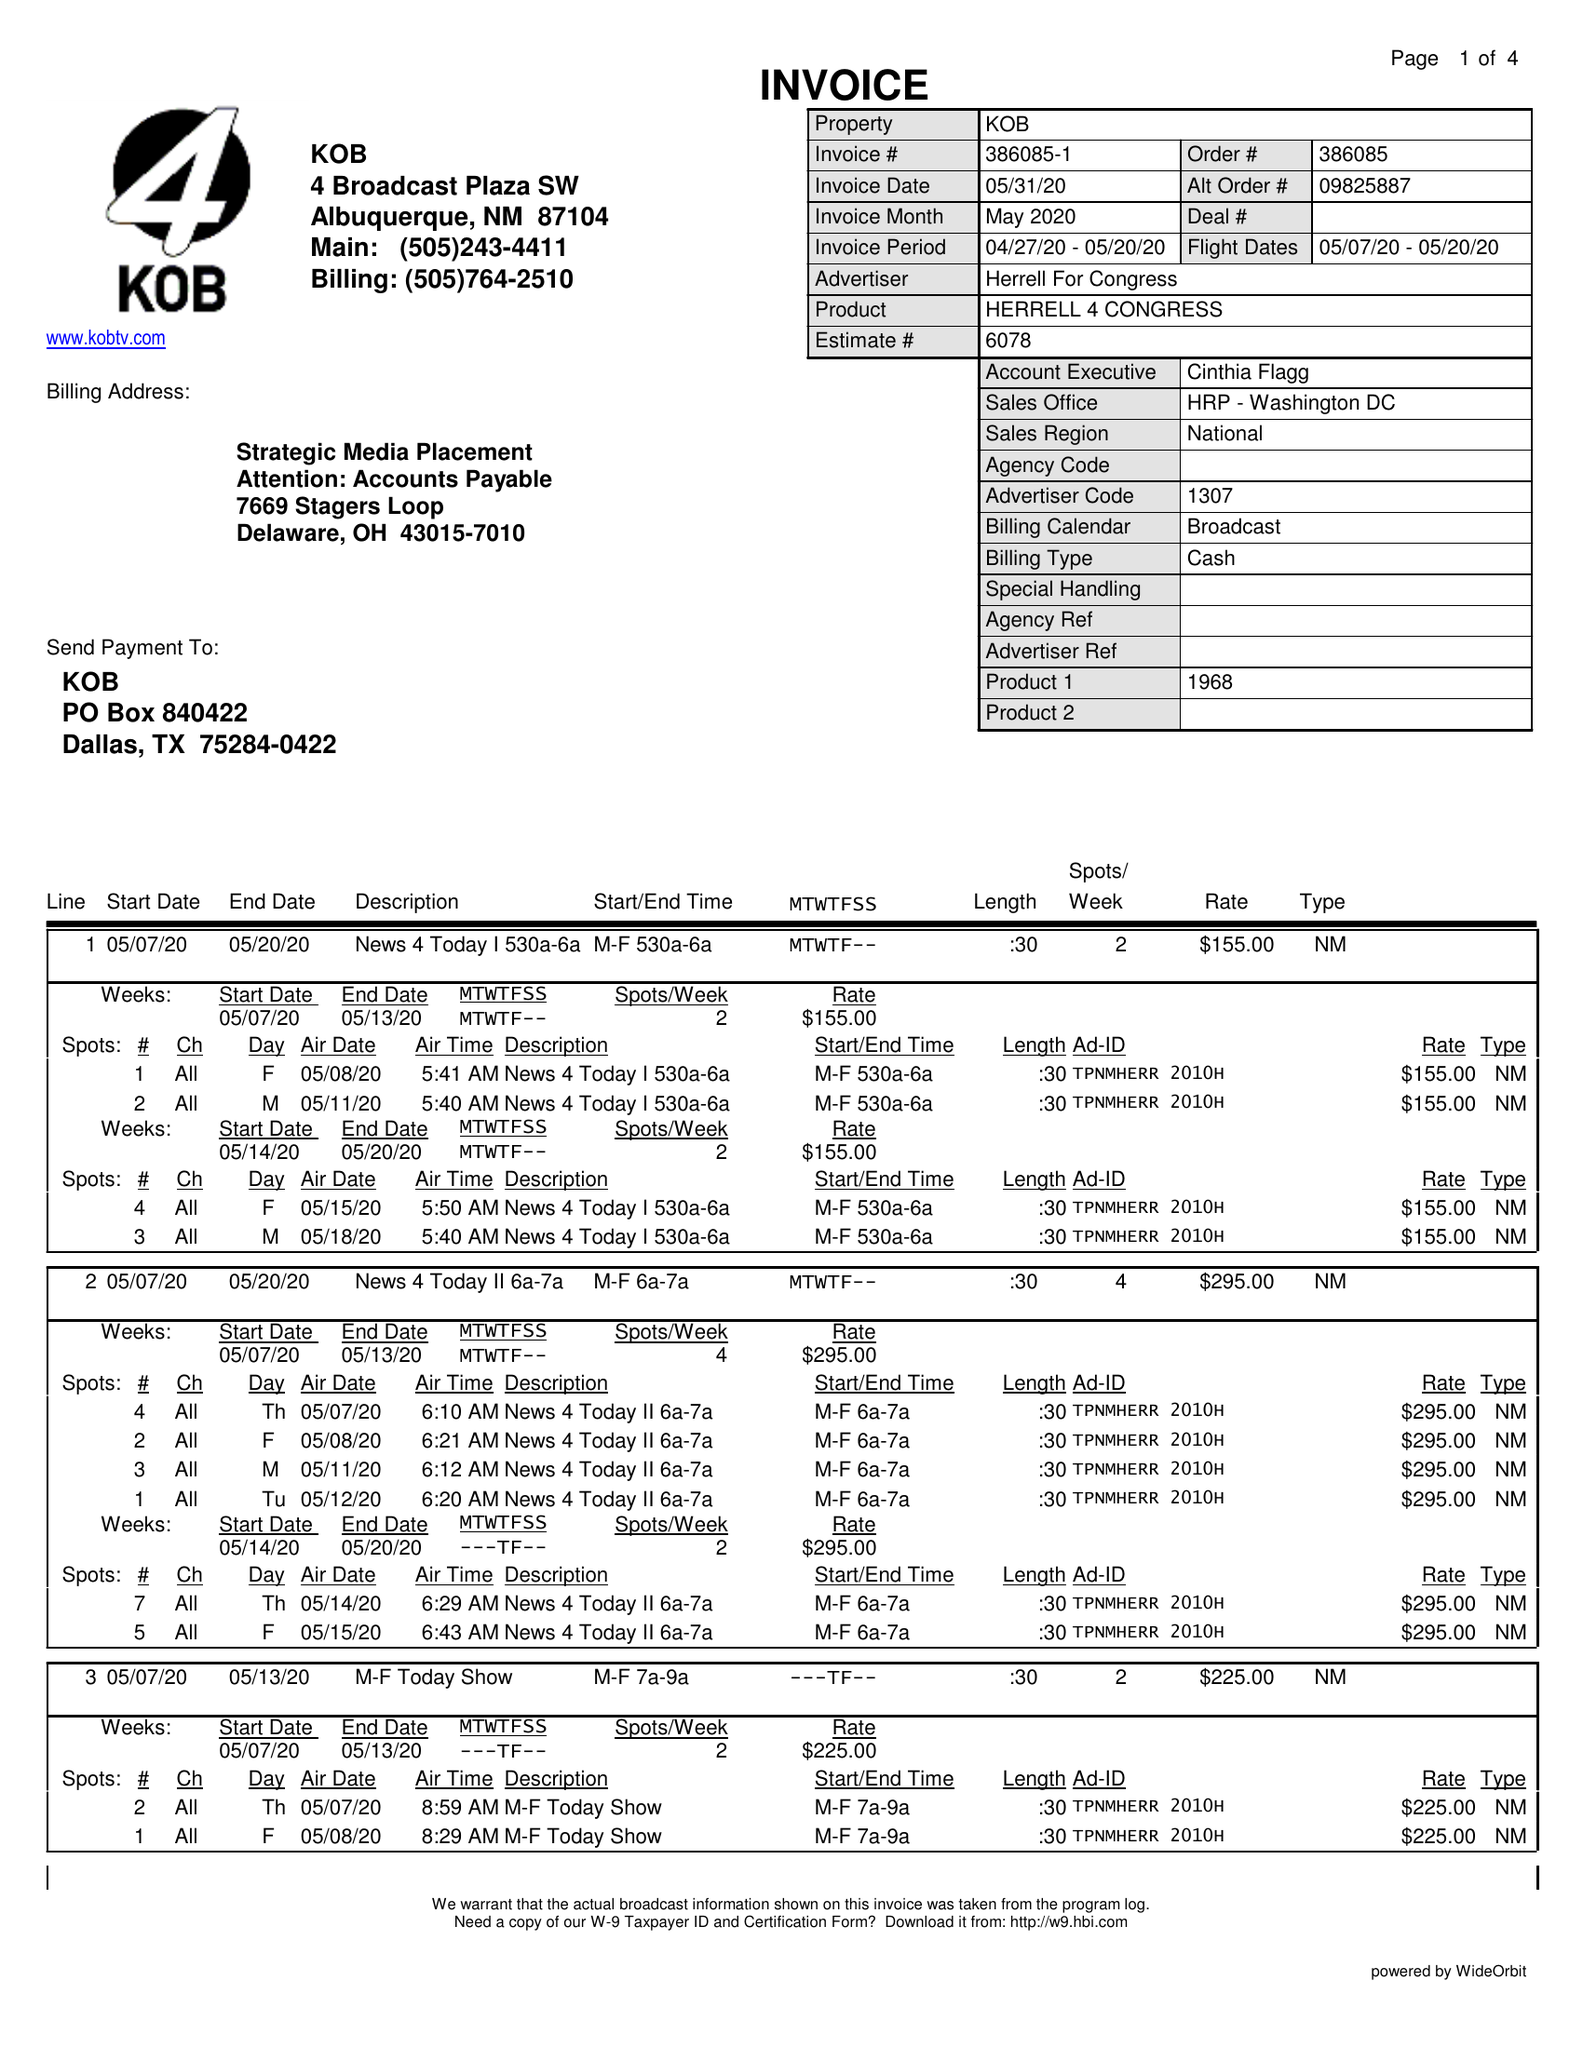What is the value for the gross_amount?
Answer the question using a single word or phrase. 13680.00 